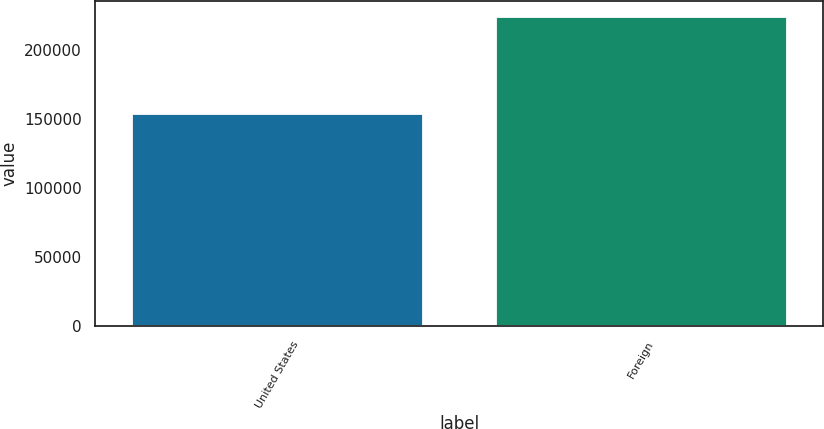Convert chart to OTSL. <chart><loc_0><loc_0><loc_500><loc_500><bar_chart><fcel>United States<fcel>Foreign<nl><fcel>153453<fcel>223897<nl></chart> 